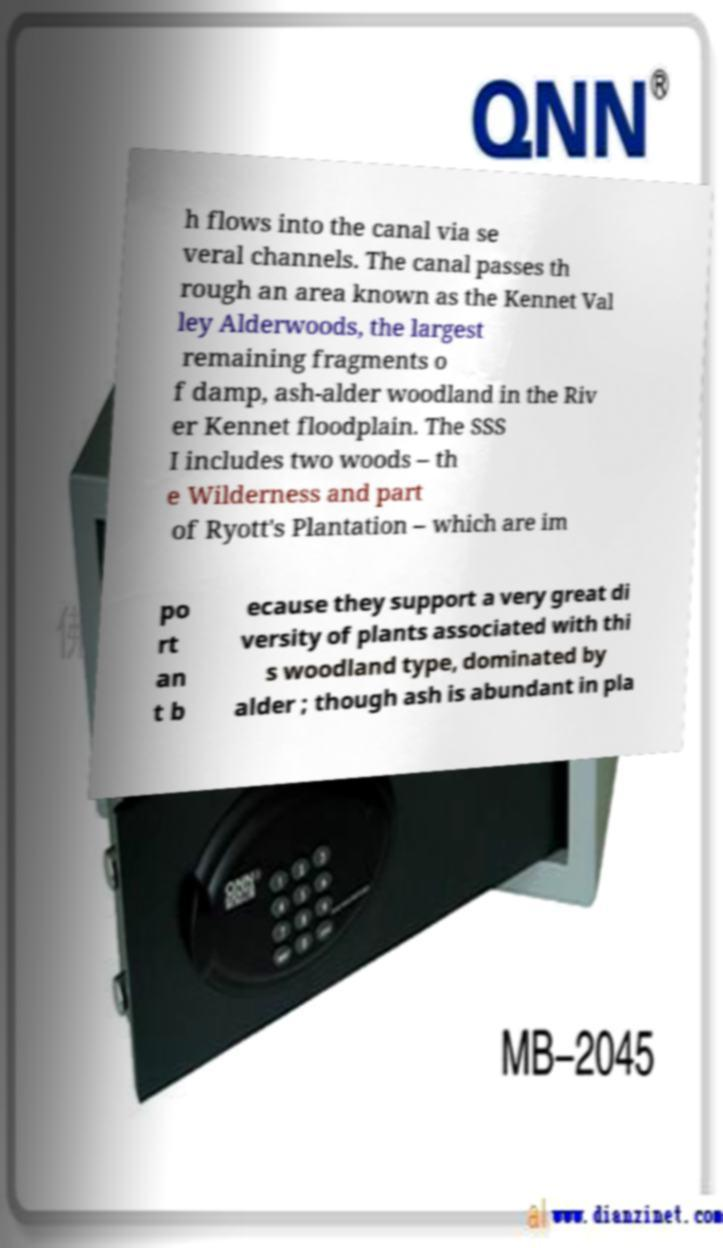Could you assist in decoding the text presented in this image and type it out clearly? h flows into the canal via se veral channels. The canal passes th rough an area known as the Kennet Val ley Alderwoods, the largest remaining fragments o f damp, ash-alder woodland in the Riv er Kennet floodplain. The SSS I includes two woods – th e Wilderness and part of Ryott's Plantation – which are im po rt an t b ecause they support a very great di versity of plants associated with thi s woodland type, dominated by alder ; though ash is abundant in pla 